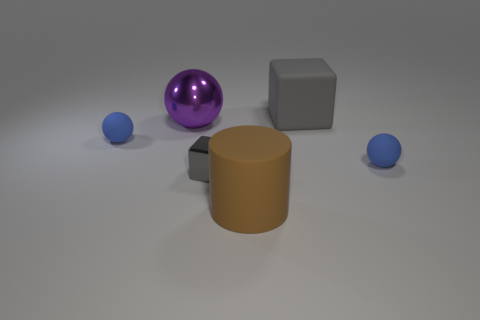What is the large object behind the shiny object that is behind the tiny object right of the tiny block made of?
Keep it short and to the point. Rubber. What material is the large thing that is the same color as the metallic cube?
Offer a very short reply. Rubber. What number of tiny blue objects are made of the same material as the large cube?
Provide a short and direct response. 2. There is a ball on the left side of the purple object; does it have the same size as the big matte cylinder?
Keep it short and to the point. No. What color is the big block that is made of the same material as the cylinder?
Offer a terse response. Gray. Is there anything else that is the same size as the metal sphere?
Ensure brevity in your answer.  Yes. There is a big purple sphere; how many large things are behind it?
Provide a succinct answer. 1. There is a tiny thing on the right side of the brown rubber cylinder; does it have the same color as the small sphere to the left of the large rubber cylinder?
Give a very brief answer. Yes. What is the color of the other large thing that is the same shape as the gray metal thing?
Keep it short and to the point. Gray. Is there anything else that has the same shape as the big gray matte object?
Offer a very short reply. Yes. 